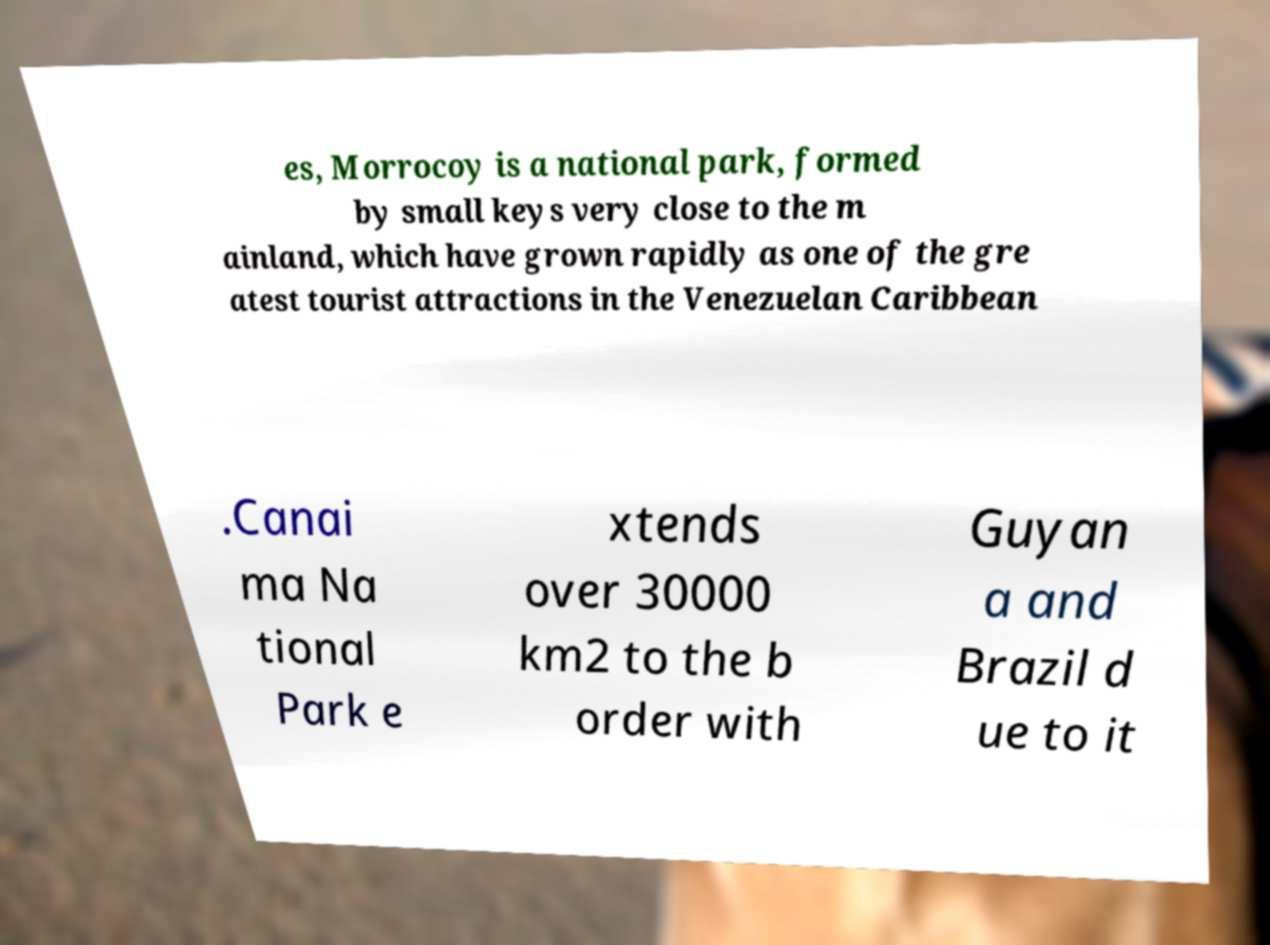Can you accurately transcribe the text from the provided image for me? es, Morrocoy is a national park, formed by small keys very close to the m ainland, which have grown rapidly as one of the gre atest tourist attractions in the Venezuelan Caribbean .Canai ma Na tional Park e xtends over 30000 km2 to the b order with Guyan a and Brazil d ue to it 